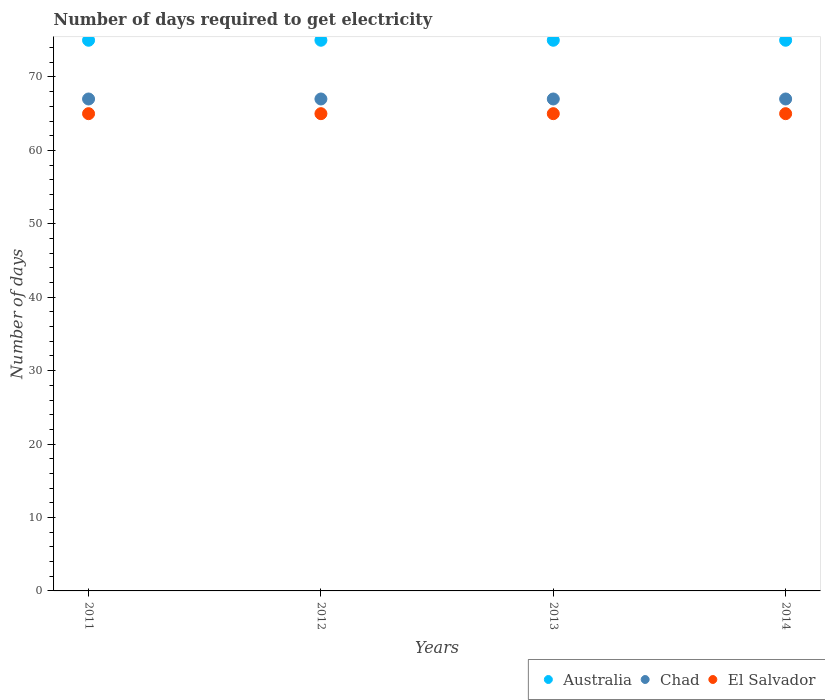What is the number of days required to get electricity in in Australia in 2014?
Provide a succinct answer. 75. Across all years, what is the maximum number of days required to get electricity in in Chad?
Make the answer very short. 67. Across all years, what is the minimum number of days required to get electricity in in Australia?
Offer a terse response. 75. In which year was the number of days required to get electricity in in Chad maximum?
Make the answer very short. 2011. In which year was the number of days required to get electricity in in El Salvador minimum?
Provide a succinct answer. 2011. What is the total number of days required to get electricity in in El Salvador in the graph?
Make the answer very short. 260. What is the difference between the number of days required to get electricity in in Chad in 2012 and that in 2013?
Your answer should be compact. 0. What is the difference between the number of days required to get electricity in in Chad in 2011 and the number of days required to get electricity in in Australia in 2013?
Your answer should be compact. -8. What is the average number of days required to get electricity in in Chad per year?
Your answer should be compact. 67. In the year 2012, what is the difference between the number of days required to get electricity in in Chad and number of days required to get electricity in in El Salvador?
Your answer should be compact. 2. In how many years, is the number of days required to get electricity in in El Salvador greater than 18 days?
Offer a very short reply. 4. In how many years, is the number of days required to get electricity in in El Salvador greater than the average number of days required to get electricity in in El Salvador taken over all years?
Provide a succinct answer. 0. Is the sum of the number of days required to get electricity in in Australia in 2012 and 2014 greater than the maximum number of days required to get electricity in in El Salvador across all years?
Your answer should be very brief. Yes. Is it the case that in every year, the sum of the number of days required to get electricity in in Chad and number of days required to get electricity in in El Salvador  is greater than the number of days required to get electricity in in Australia?
Your response must be concise. Yes. How many dotlines are there?
Offer a terse response. 3. How many years are there in the graph?
Offer a very short reply. 4. Does the graph contain grids?
Provide a succinct answer. No. Where does the legend appear in the graph?
Your answer should be very brief. Bottom right. How many legend labels are there?
Provide a succinct answer. 3. What is the title of the graph?
Your answer should be compact. Number of days required to get electricity. Does "Belarus" appear as one of the legend labels in the graph?
Provide a succinct answer. No. What is the label or title of the X-axis?
Offer a terse response. Years. What is the label or title of the Y-axis?
Make the answer very short. Number of days. What is the Number of days of Australia in 2011?
Your response must be concise. 75. What is the Number of days in Chad in 2013?
Ensure brevity in your answer.  67. What is the Number of days in El Salvador in 2013?
Provide a short and direct response. 65. Across all years, what is the maximum Number of days in Chad?
Provide a succinct answer. 67. Across all years, what is the maximum Number of days in El Salvador?
Your answer should be compact. 65. Across all years, what is the minimum Number of days of Australia?
Your response must be concise. 75. Across all years, what is the minimum Number of days in El Salvador?
Your answer should be compact. 65. What is the total Number of days in Australia in the graph?
Offer a very short reply. 300. What is the total Number of days of Chad in the graph?
Your answer should be compact. 268. What is the total Number of days in El Salvador in the graph?
Your answer should be compact. 260. What is the difference between the Number of days in Australia in 2011 and that in 2012?
Make the answer very short. 0. What is the difference between the Number of days of Chad in 2011 and that in 2012?
Offer a terse response. 0. What is the difference between the Number of days of El Salvador in 2011 and that in 2012?
Ensure brevity in your answer.  0. What is the difference between the Number of days in Australia in 2011 and that in 2013?
Your answer should be compact. 0. What is the difference between the Number of days in Chad in 2011 and that in 2013?
Offer a terse response. 0. What is the difference between the Number of days of Chad in 2012 and that in 2013?
Provide a succinct answer. 0. What is the difference between the Number of days in Australia in 2012 and that in 2014?
Offer a terse response. 0. What is the difference between the Number of days of Chad in 2012 and that in 2014?
Offer a terse response. 0. What is the difference between the Number of days of Australia in 2011 and the Number of days of Chad in 2012?
Offer a very short reply. 8. What is the difference between the Number of days in Australia in 2011 and the Number of days in El Salvador in 2012?
Provide a succinct answer. 10. What is the difference between the Number of days of Australia in 2011 and the Number of days of Chad in 2013?
Offer a terse response. 8. What is the difference between the Number of days of Australia in 2011 and the Number of days of El Salvador in 2013?
Your answer should be very brief. 10. What is the difference between the Number of days of Chad in 2011 and the Number of days of El Salvador in 2014?
Give a very brief answer. 2. What is the difference between the Number of days of Australia in 2012 and the Number of days of El Salvador in 2013?
Offer a terse response. 10. What is the difference between the Number of days in Australia in 2012 and the Number of days in Chad in 2014?
Provide a succinct answer. 8. What is the difference between the Number of days of Australia in 2013 and the Number of days of Chad in 2014?
Make the answer very short. 8. What is the difference between the Number of days of Australia in 2013 and the Number of days of El Salvador in 2014?
Offer a terse response. 10. What is the difference between the Number of days of Chad in 2013 and the Number of days of El Salvador in 2014?
Make the answer very short. 2. In the year 2011, what is the difference between the Number of days of Australia and Number of days of Chad?
Your response must be concise. 8. In the year 2011, what is the difference between the Number of days in Chad and Number of days in El Salvador?
Your answer should be compact. 2. In the year 2012, what is the difference between the Number of days of Australia and Number of days of Chad?
Offer a terse response. 8. In the year 2012, what is the difference between the Number of days of Chad and Number of days of El Salvador?
Your answer should be very brief. 2. In the year 2013, what is the difference between the Number of days of Chad and Number of days of El Salvador?
Give a very brief answer. 2. In the year 2014, what is the difference between the Number of days of Australia and Number of days of Chad?
Give a very brief answer. 8. In the year 2014, what is the difference between the Number of days of Australia and Number of days of El Salvador?
Your answer should be compact. 10. In the year 2014, what is the difference between the Number of days in Chad and Number of days in El Salvador?
Your answer should be compact. 2. What is the ratio of the Number of days of Australia in 2011 to that in 2012?
Provide a short and direct response. 1. What is the ratio of the Number of days of El Salvador in 2011 to that in 2012?
Provide a short and direct response. 1. What is the ratio of the Number of days of Chad in 2011 to that in 2013?
Provide a succinct answer. 1. What is the ratio of the Number of days in El Salvador in 2011 to that in 2013?
Make the answer very short. 1. What is the ratio of the Number of days of Australia in 2011 to that in 2014?
Your response must be concise. 1. What is the ratio of the Number of days of El Salvador in 2011 to that in 2014?
Your answer should be compact. 1. What is the ratio of the Number of days in Australia in 2012 to that in 2013?
Offer a terse response. 1. What is the ratio of the Number of days in El Salvador in 2012 to that in 2013?
Make the answer very short. 1. What is the ratio of the Number of days of Chad in 2012 to that in 2014?
Your answer should be compact. 1. What is the ratio of the Number of days of Australia in 2013 to that in 2014?
Your answer should be compact. 1. What is the difference between the highest and the second highest Number of days of Australia?
Keep it short and to the point. 0. What is the difference between the highest and the second highest Number of days in Chad?
Offer a terse response. 0. What is the difference between the highest and the second highest Number of days of El Salvador?
Offer a very short reply. 0. What is the difference between the highest and the lowest Number of days in Australia?
Make the answer very short. 0. What is the difference between the highest and the lowest Number of days in El Salvador?
Your answer should be very brief. 0. 